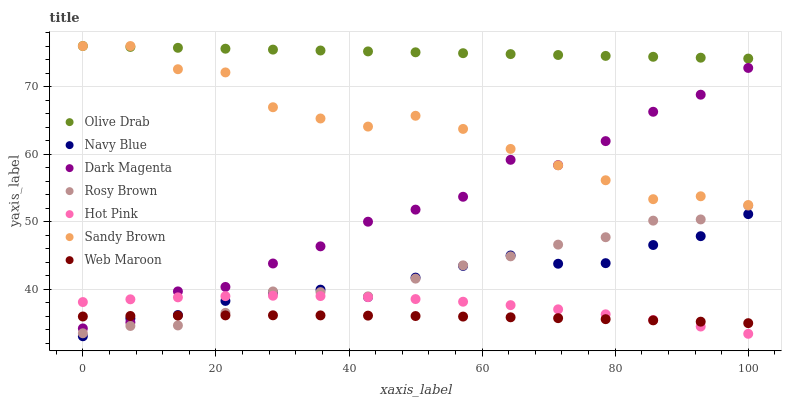Does Web Maroon have the minimum area under the curve?
Answer yes or no. Yes. Does Olive Drab have the maximum area under the curve?
Answer yes or no. Yes. Does Dark Magenta have the minimum area under the curve?
Answer yes or no. No. Does Dark Magenta have the maximum area under the curve?
Answer yes or no. No. Is Olive Drab the smoothest?
Answer yes or no. Yes. Is Dark Magenta the roughest?
Answer yes or no. Yes. Is Navy Blue the smoothest?
Answer yes or no. No. Is Navy Blue the roughest?
Answer yes or no. No. Does Navy Blue have the lowest value?
Answer yes or no. Yes. Does Dark Magenta have the lowest value?
Answer yes or no. No. Does Olive Drab have the highest value?
Answer yes or no. Yes. Does Dark Magenta have the highest value?
Answer yes or no. No. Is Rosy Brown less than Olive Drab?
Answer yes or no. Yes. Is Dark Magenta greater than Rosy Brown?
Answer yes or no. Yes. Does Web Maroon intersect Hot Pink?
Answer yes or no. Yes. Is Web Maroon less than Hot Pink?
Answer yes or no. No. Is Web Maroon greater than Hot Pink?
Answer yes or no. No. Does Rosy Brown intersect Olive Drab?
Answer yes or no. No. 